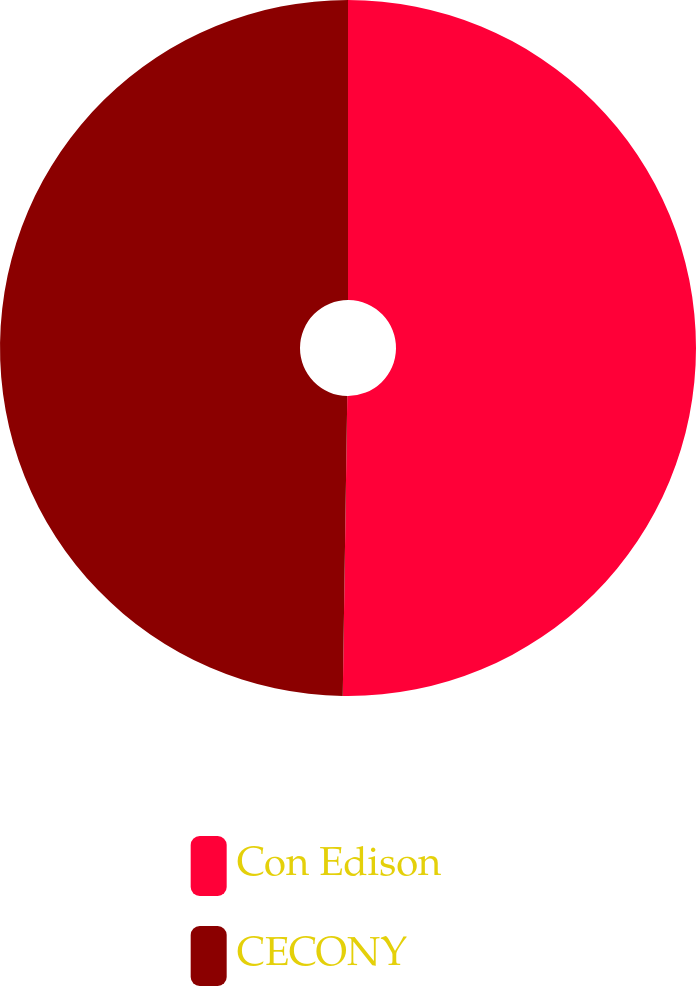Convert chart. <chart><loc_0><loc_0><loc_500><loc_500><pie_chart><fcel>Con Edison<fcel>CECONY<nl><fcel>50.24%<fcel>49.76%<nl></chart> 